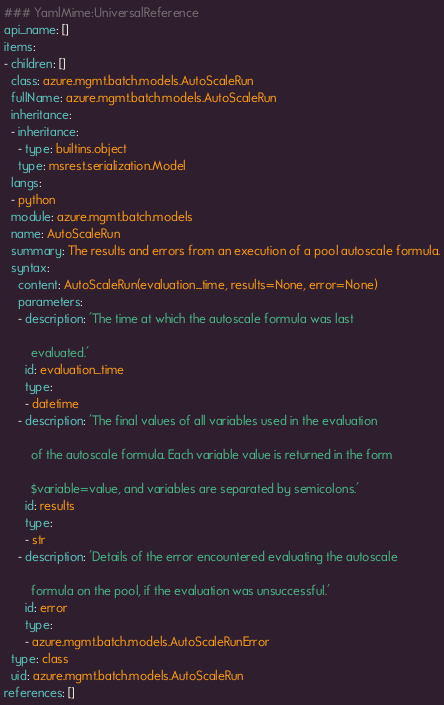Convert code to text. <code><loc_0><loc_0><loc_500><loc_500><_YAML_>### YamlMime:UniversalReference
api_name: []
items:
- children: []
  class: azure.mgmt.batch.models.AutoScaleRun
  fullName: azure.mgmt.batch.models.AutoScaleRun
  inheritance:
  - inheritance:
    - type: builtins.object
    type: msrest.serialization.Model
  langs:
  - python
  module: azure.mgmt.batch.models
  name: AutoScaleRun
  summary: The results and errors from an execution of a pool autoscale formula.
  syntax:
    content: AutoScaleRun(evaluation_time, results=None, error=None)
    parameters:
    - description: 'The time at which the autoscale formula was last

        evaluated.'
      id: evaluation_time
      type:
      - datetime
    - description: 'The final values of all variables used in the evaluation

        of the autoscale formula. Each variable value is returned in the form

        $variable=value, and variables are separated by semicolons.'
      id: results
      type:
      - str
    - description: 'Details of the error encountered evaluating the autoscale

        formula on the pool, if the evaluation was unsuccessful.'
      id: error
      type:
      - azure.mgmt.batch.models.AutoScaleRunError
  type: class
  uid: azure.mgmt.batch.models.AutoScaleRun
references: []
</code> 